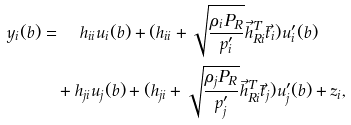Convert formula to latex. <formula><loc_0><loc_0><loc_500><loc_500>y _ { i } ( b ) = & \ \quad h _ { i i } u _ { i } ( b ) + ( h _ { i i } + \sqrt { \frac { \rho _ { i } P _ { R } } { p _ { i } ^ { \prime } } } \vec { h } _ { R i } ^ { T } \vec { t } _ { i } ) u _ { i } ^ { \prime } ( b ) \\ & + h _ { j i } u _ { j } ( b ) + ( h _ { j i } + \sqrt { \frac { \rho _ { j } P _ { R } } { p _ { j } ^ { \prime } } } \vec { h } _ { R i } ^ { T } \vec { t } _ { j } ) u _ { j } ^ { \prime } ( b ) + z _ { i } ,</formula> 